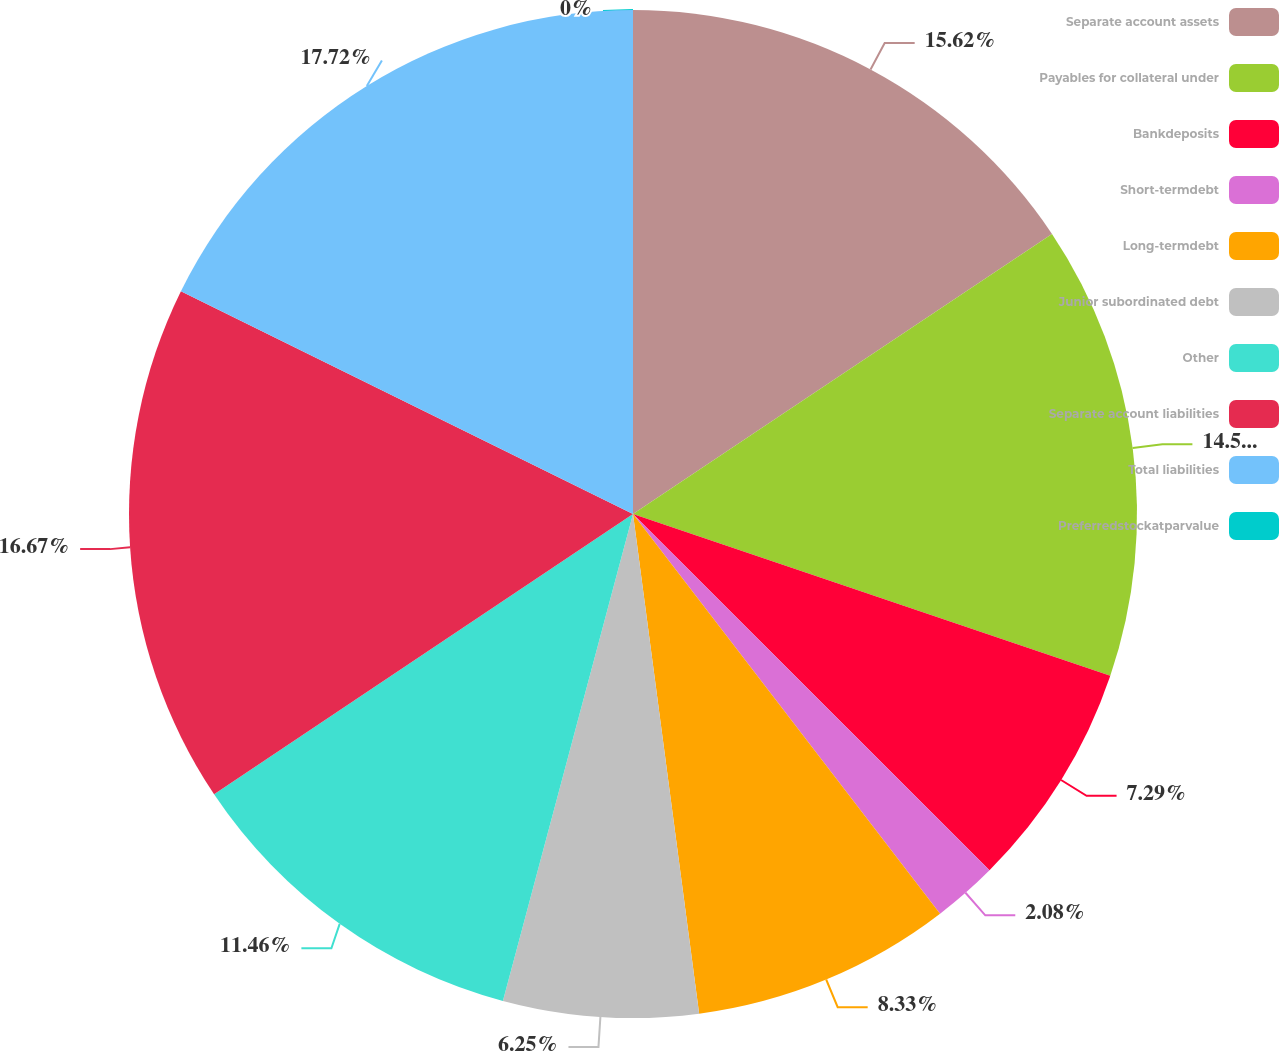Convert chart. <chart><loc_0><loc_0><loc_500><loc_500><pie_chart><fcel>Separate account assets<fcel>Payables for collateral under<fcel>Bankdeposits<fcel>Short-termdebt<fcel>Long-termdebt<fcel>Junior subordinated debt<fcel>Other<fcel>Separate account liabilities<fcel>Total liabilities<fcel>Preferredstockatparvalue<nl><fcel>15.62%<fcel>14.58%<fcel>7.29%<fcel>2.08%<fcel>8.33%<fcel>6.25%<fcel>11.46%<fcel>16.67%<fcel>17.71%<fcel>0.0%<nl></chart> 